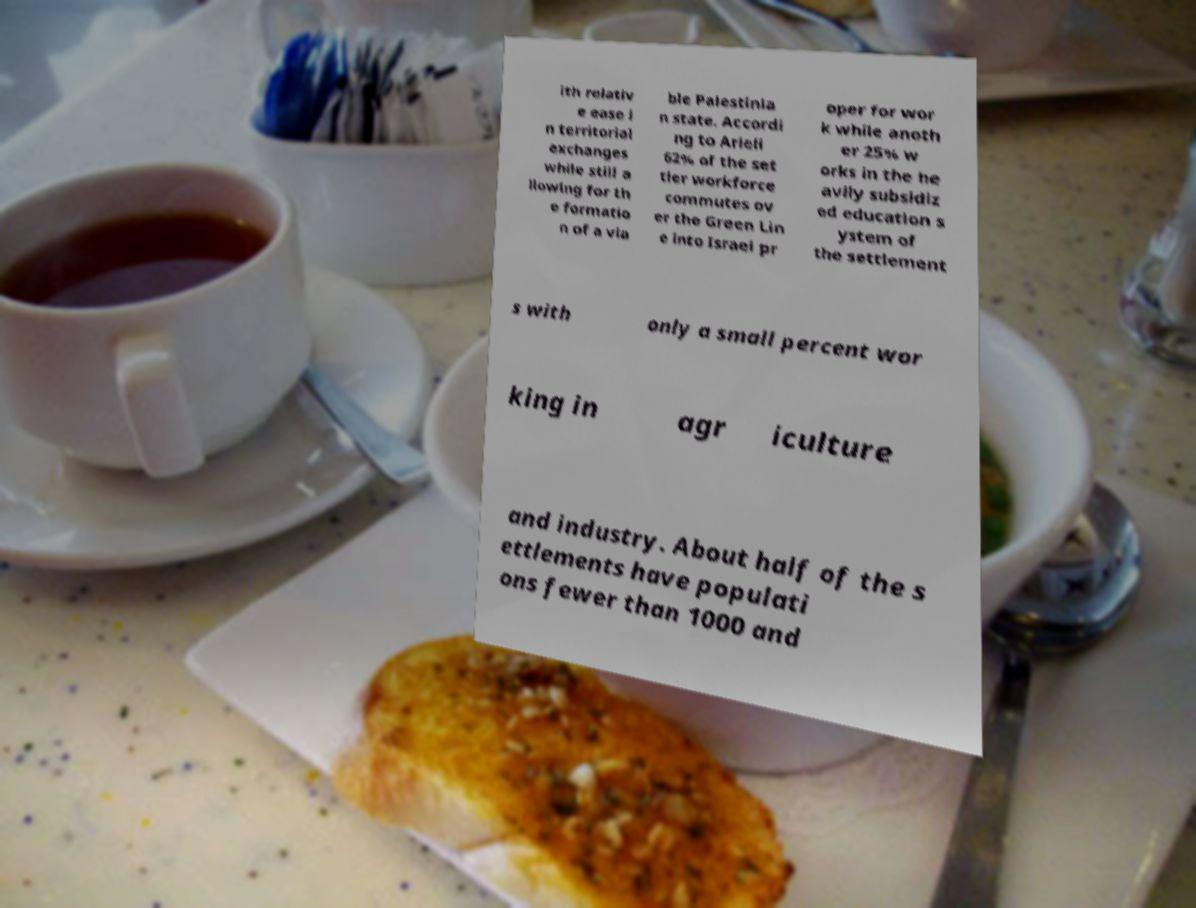I need the written content from this picture converted into text. Can you do that? ith relativ e ease i n territorial exchanges while still a llowing for th e formatio n of a via ble Palestinia n state. Accordi ng to Arieli 62% of the set tler workforce commutes ov er the Green Lin e into Israel pr oper for wor k while anoth er 25% w orks in the he avily subsidiz ed education s ystem of the settlement s with only a small percent wor king in agr iculture and industry. About half of the s ettlements have populati ons fewer than 1000 and 